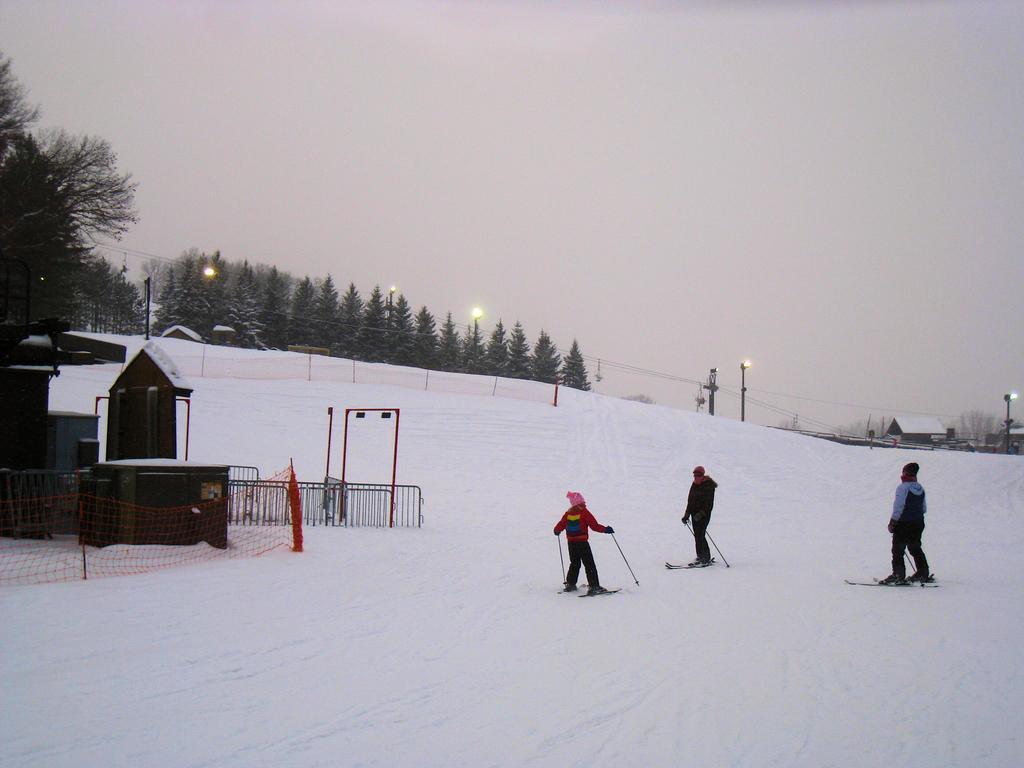How would you summarize this image in a sentence or two? Here in this picture we can see a group of people present on the ground, which is fully covered with snow and all of them are having ski boards under their legs and holding sticks and wearing jackets and caps and on the left side we can see a house present and in the front we can see railing present and in the far we can see plants and trees present and we can also see light posts present and we can also see other houses present and we can see the sky is cloudy. 